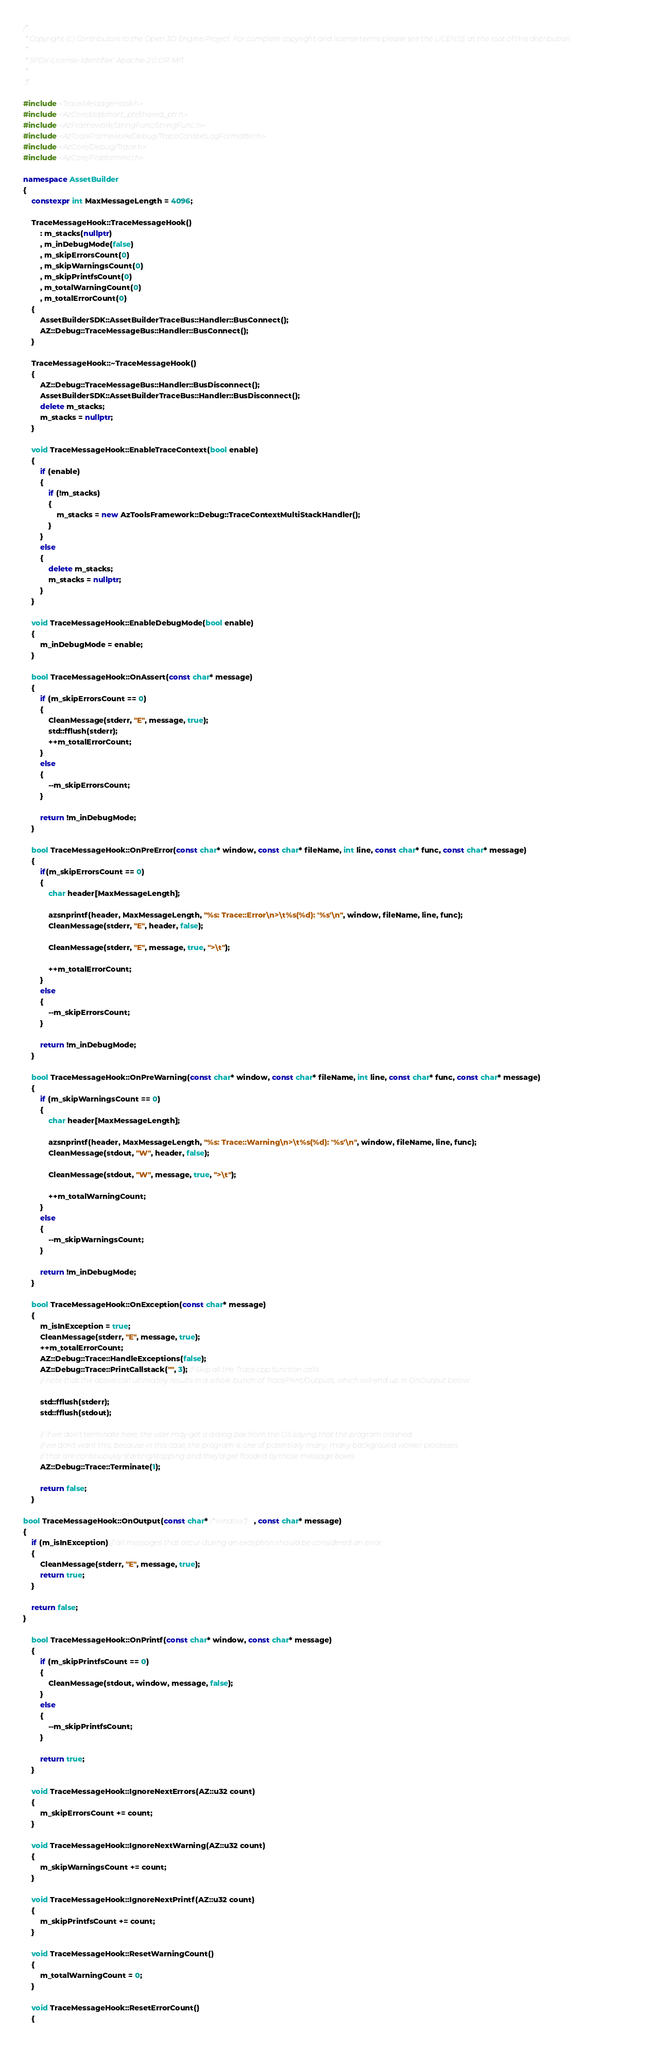<code> <loc_0><loc_0><loc_500><loc_500><_C++_>/*
 * Copyright (c) Contributors to the Open 3D Engine Project. For complete copyright and license terms please see the LICENSE at the root of this distribution.
 * 
 * SPDX-License-Identifier: Apache-2.0 OR MIT
 *
 */

#include <TraceMessageHook.h>
#include <AzCore/std/smart_ptr/shared_ptr.h>
#include <AzFramework/StringFunc/StringFunc.h>
#include <AzToolsFramework/Debug/TraceContextLogFormatter.h>
#include <AzCore/Debug/Trace.h>
#include <AzCore/PlatformIncl.h>

namespace AssetBuilder
{
    constexpr int MaxMessageLength = 4096;

    TraceMessageHook::TraceMessageHook()
        : m_stacks(nullptr)
        , m_inDebugMode(false)
        , m_skipErrorsCount(0)
        , m_skipWarningsCount(0)
        , m_skipPrintfsCount(0)
        , m_totalWarningCount(0)
        , m_totalErrorCount(0)
    {
        AssetBuilderSDK::AssetBuilderTraceBus::Handler::BusConnect();
        AZ::Debug::TraceMessageBus::Handler::BusConnect();
    }

    TraceMessageHook::~TraceMessageHook()
    {
        AZ::Debug::TraceMessageBus::Handler::BusDisconnect();
        AssetBuilderSDK::AssetBuilderTraceBus::Handler::BusDisconnect();
        delete m_stacks;
        m_stacks = nullptr;
    }

    void TraceMessageHook::EnableTraceContext(bool enable)
    {
        if (enable)
        {
            if (!m_stacks)
            {
                m_stacks = new AzToolsFramework::Debug::TraceContextMultiStackHandler();
            }
        }
        else
        {
            delete m_stacks;
            m_stacks = nullptr;
        }
    }

    void TraceMessageHook::EnableDebugMode(bool enable)
    {
        m_inDebugMode = enable;
    }

    bool TraceMessageHook::OnAssert(const char* message)
    {
        if (m_skipErrorsCount == 0)
        {
            CleanMessage(stderr, "E", message, true);
            std::fflush(stderr);
            ++m_totalErrorCount;
        }
        else
        {
            --m_skipErrorsCount;
        }

        return !m_inDebugMode;
    }

    bool TraceMessageHook::OnPreError(const char* window, const char* fileName, int line, const char* func, const char* message)
    {
        if(m_skipErrorsCount == 0)
        {
            char header[MaxMessageLength];

            azsnprintf(header, MaxMessageLength, "%s: Trace::Error\n>\t%s(%d): '%s'\n", window, fileName, line, func);
            CleanMessage(stderr, "E", header, false);

            CleanMessage(stderr, "E", message, true, ">\t");

            ++m_totalErrorCount;
        }
        else
        {
            --m_skipErrorsCount;
        }

        return !m_inDebugMode;
    }

    bool TraceMessageHook::OnPreWarning(const char* window, const char* fileName, int line, const char* func, const char* message)
    {
        if (m_skipWarningsCount == 0)
        {
            char header[MaxMessageLength];

            azsnprintf(header, MaxMessageLength, "%s: Trace::Warning\n>\t%s(%d): '%s'\n", window, fileName, line, func);
            CleanMessage(stdout, "W", header, false);

            CleanMessage(stdout, "W", message, true, ">\t");

            ++m_totalWarningCount;
        }
        else
        {
            --m_skipWarningsCount;
        }

        return !m_inDebugMode;
    }

    bool TraceMessageHook::OnException(const char* message)
    {
        m_isInException = true;
        CleanMessage(stderr, "E", message, true);
        ++m_totalErrorCount;
        AZ::Debug::Trace::HandleExceptions(false);
        AZ::Debug::Trace::PrintCallstack("", 3); // Skip all the Trace.cpp function calls
        // note that the above call ultimately results in a whole bunch of TracePrint/Outputs, which will end up in OnOutput below.

        std::fflush(stderr);
        std::fflush(stdout);

        // if we don't terminate here, the user may get a dialog box from the OS saying that the program crashed.
        // we don't want this, because in this case, the program is one of potentially many, many background worker processes
        // that are continuously starting/stopping and they'd get flooded by those message boxes.
        AZ::Debug::Trace::Terminate(1);

        return false;
    }

bool TraceMessageHook::OnOutput(const char* /*window*/, const char* message)
{
    if (m_isInException) // all messages that occur during an exception should be considered an error.
    {
        CleanMessage(stderr, "E", message, true);
        return true;
    }
    
    return false;
}

    bool TraceMessageHook::OnPrintf(const char* window, const char* message)
    {
        if (m_skipPrintfsCount == 0)
        {
            CleanMessage(stdout, window, message, false);
        }
        else
        {
            --m_skipPrintfsCount;
        }
        
        return true;
    }

    void TraceMessageHook::IgnoreNextErrors(AZ::u32 count)
    {
        m_skipErrorsCount += count;
    }

    void TraceMessageHook::IgnoreNextWarning(AZ::u32 count)
    {
        m_skipWarningsCount += count;
    }

    void TraceMessageHook::IgnoreNextPrintf(AZ::u32 count)
    {
        m_skipPrintfsCount += count;
    }

    void TraceMessageHook::ResetWarningCount()
    {
        m_totalWarningCount = 0;
    }

    void TraceMessageHook::ResetErrorCount()
    {</code> 